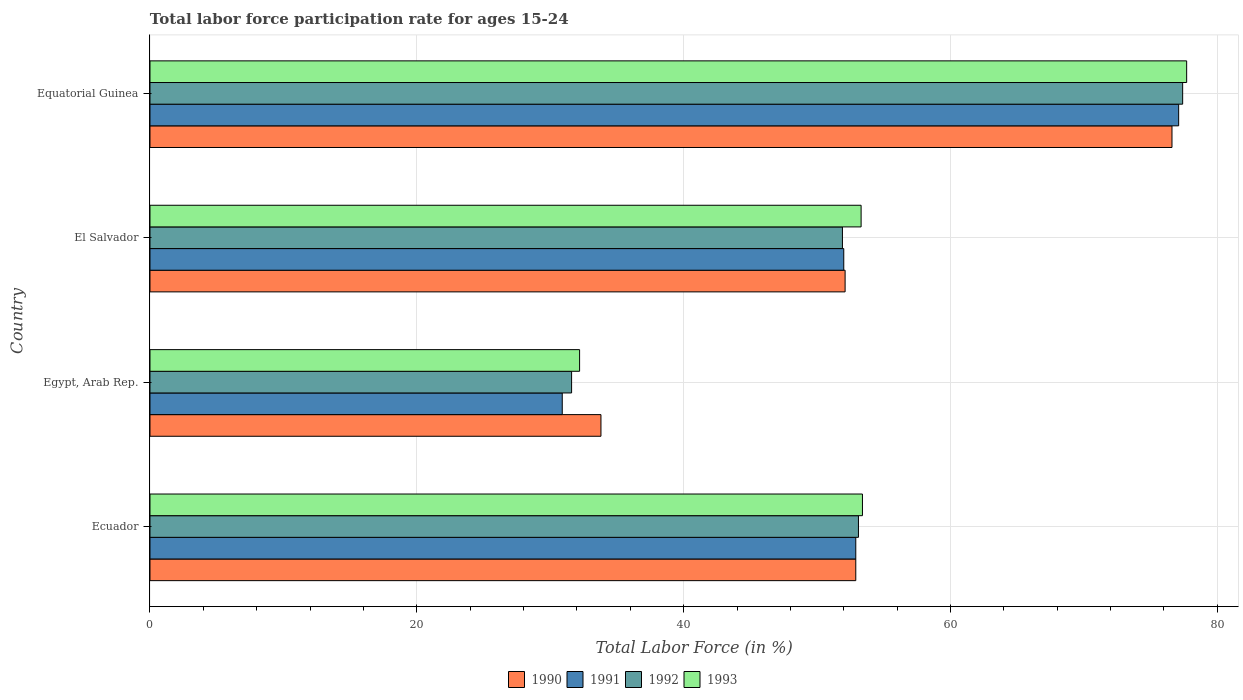How many different coloured bars are there?
Your answer should be very brief. 4. How many groups of bars are there?
Offer a terse response. 4. How many bars are there on the 4th tick from the bottom?
Ensure brevity in your answer.  4. What is the label of the 4th group of bars from the top?
Ensure brevity in your answer.  Ecuador. What is the labor force participation rate in 1991 in Egypt, Arab Rep.?
Provide a short and direct response. 30.9. Across all countries, what is the maximum labor force participation rate in 1990?
Make the answer very short. 76.6. Across all countries, what is the minimum labor force participation rate in 1991?
Your response must be concise. 30.9. In which country was the labor force participation rate in 1992 maximum?
Your response must be concise. Equatorial Guinea. In which country was the labor force participation rate in 1992 minimum?
Offer a terse response. Egypt, Arab Rep. What is the total labor force participation rate in 1990 in the graph?
Keep it short and to the point. 215.4. What is the difference between the labor force participation rate in 1993 in Egypt, Arab Rep. and that in El Salvador?
Your response must be concise. -21.1. What is the difference between the labor force participation rate in 1990 in Ecuador and the labor force participation rate in 1992 in Equatorial Guinea?
Your answer should be very brief. -24.5. What is the average labor force participation rate in 1991 per country?
Your answer should be very brief. 53.22. What is the difference between the labor force participation rate in 1992 and labor force participation rate in 1991 in El Salvador?
Offer a very short reply. -0.1. What is the ratio of the labor force participation rate in 1990 in Egypt, Arab Rep. to that in El Salvador?
Keep it short and to the point. 0.65. What is the difference between the highest and the second highest labor force participation rate in 1993?
Give a very brief answer. 24.3. What is the difference between the highest and the lowest labor force participation rate in 1993?
Keep it short and to the point. 45.5. In how many countries, is the labor force participation rate in 1991 greater than the average labor force participation rate in 1991 taken over all countries?
Make the answer very short. 1. What does the 4th bar from the top in Ecuador represents?
Make the answer very short. 1990. What does the 1st bar from the bottom in Ecuador represents?
Make the answer very short. 1990. How many bars are there?
Your answer should be compact. 16. How many countries are there in the graph?
Keep it short and to the point. 4. What is the difference between two consecutive major ticks on the X-axis?
Your response must be concise. 20. Are the values on the major ticks of X-axis written in scientific E-notation?
Provide a succinct answer. No. Does the graph contain grids?
Your response must be concise. Yes. Where does the legend appear in the graph?
Offer a very short reply. Bottom center. What is the title of the graph?
Ensure brevity in your answer.  Total labor force participation rate for ages 15-24. Does "1983" appear as one of the legend labels in the graph?
Give a very brief answer. No. What is the Total Labor Force (in %) of 1990 in Ecuador?
Provide a succinct answer. 52.9. What is the Total Labor Force (in %) in 1991 in Ecuador?
Give a very brief answer. 52.9. What is the Total Labor Force (in %) in 1992 in Ecuador?
Ensure brevity in your answer.  53.1. What is the Total Labor Force (in %) in 1993 in Ecuador?
Give a very brief answer. 53.4. What is the Total Labor Force (in %) of 1990 in Egypt, Arab Rep.?
Provide a short and direct response. 33.8. What is the Total Labor Force (in %) of 1991 in Egypt, Arab Rep.?
Provide a short and direct response. 30.9. What is the Total Labor Force (in %) in 1992 in Egypt, Arab Rep.?
Your response must be concise. 31.6. What is the Total Labor Force (in %) of 1993 in Egypt, Arab Rep.?
Provide a succinct answer. 32.2. What is the Total Labor Force (in %) of 1990 in El Salvador?
Your answer should be compact. 52.1. What is the Total Labor Force (in %) of 1991 in El Salvador?
Keep it short and to the point. 52. What is the Total Labor Force (in %) of 1992 in El Salvador?
Your answer should be compact. 51.9. What is the Total Labor Force (in %) in 1993 in El Salvador?
Provide a succinct answer. 53.3. What is the Total Labor Force (in %) in 1990 in Equatorial Guinea?
Provide a succinct answer. 76.6. What is the Total Labor Force (in %) of 1991 in Equatorial Guinea?
Your response must be concise. 77.1. What is the Total Labor Force (in %) in 1992 in Equatorial Guinea?
Make the answer very short. 77.4. What is the Total Labor Force (in %) of 1993 in Equatorial Guinea?
Make the answer very short. 77.7. Across all countries, what is the maximum Total Labor Force (in %) of 1990?
Offer a terse response. 76.6. Across all countries, what is the maximum Total Labor Force (in %) in 1991?
Your answer should be compact. 77.1. Across all countries, what is the maximum Total Labor Force (in %) of 1992?
Your answer should be compact. 77.4. Across all countries, what is the maximum Total Labor Force (in %) of 1993?
Offer a very short reply. 77.7. Across all countries, what is the minimum Total Labor Force (in %) in 1990?
Offer a terse response. 33.8. Across all countries, what is the minimum Total Labor Force (in %) of 1991?
Keep it short and to the point. 30.9. Across all countries, what is the minimum Total Labor Force (in %) of 1992?
Offer a very short reply. 31.6. Across all countries, what is the minimum Total Labor Force (in %) of 1993?
Offer a terse response. 32.2. What is the total Total Labor Force (in %) in 1990 in the graph?
Make the answer very short. 215.4. What is the total Total Labor Force (in %) of 1991 in the graph?
Make the answer very short. 212.9. What is the total Total Labor Force (in %) in 1992 in the graph?
Make the answer very short. 214. What is the total Total Labor Force (in %) in 1993 in the graph?
Give a very brief answer. 216.6. What is the difference between the Total Labor Force (in %) in 1993 in Ecuador and that in Egypt, Arab Rep.?
Give a very brief answer. 21.2. What is the difference between the Total Labor Force (in %) of 1991 in Ecuador and that in El Salvador?
Provide a short and direct response. 0.9. What is the difference between the Total Labor Force (in %) of 1993 in Ecuador and that in El Salvador?
Keep it short and to the point. 0.1. What is the difference between the Total Labor Force (in %) of 1990 in Ecuador and that in Equatorial Guinea?
Offer a very short reply. -23.7. What is the difference between the Total Labor Force (in %) of 1991 in Ecuador and that in Equatorial Guinea?
Offer a very short reply. -24.2. What is the difference between the Total Labor Force (in %) of 1992 in Ecuador and that in Equatorial Guinea?
Offer a terse response. -24.3. What is the difference between the Total Labor Force (in %) of 1993 in Ecuador and that in Equatorial Guinea?
Ensure brevity in your answer.  -24.3. What is the difference between the Total Labor Force (in %) of 1990 in Egypt, Arab Rep. and that in El Salvador?
Provide a short and direct response. -18.3. What is the difference between the Total Labor Force (in %) of 1991 in Egypt, Arab Rep. and that in El Salvador?
Make the answer very short. -21.1. What is the difference between the Total Labor Force (in %) of 1992 in Egypt, Arab Rep. and that in El Salvador?
Your answer should be compact. -20.3. What is the difference between the Total Labor Force (in %) in 1993 in Egypt, Arab Rep. and that in El Salvador?
Provide a short and direct response. -21.1. What is the difference between the Total Labor Force (in %) of 1990 in Egypt, Arab Rep. and that in Equatorial Guinea?
Provide a short and direct response. -42.8. What is the difference between the Total Labor Force (in %) in 1991 in Egypt, Arab Rep. and that in Equatorial Guinea?
Provide a succinct answer. -46.2. What is the difference between the Total Labor Force (in %) in 1992 in Egypt, Arab Rep. and that in Equatorial Guinea?
Provide a succinct answer. -45.8. What is the difference between the Total Labor Force (in %) in 1993 in Egypt, Arab Rep. and that in Equatorial Guinea?
Offer a very short reply. -45.5. What is the difference between the Total Labor Force (in %) of 1990 in El Salvador and that in Equatorial Guinea?
Ensure brevity in your answer.  -24.5. What is the difference between the Total Labor Force (in %) in 1991 in El Salvador and that in Equatorial Guinea?
Offer a very short reply. -25.1. What is the difference between the Total Labor Force (in %) of 1992 in El Salvador and that in Equatorial Guinea?
Offer a very short reply. -25.5. What is the difference between the Total Labor Force (in %) of 1993 in El Salvador and that in Equatorial Guinea?
Offer a very short reply. -24.4. What is the difference between the Total Labor Force (in %) in 1990 in Ecuador and the Total Labor Force (in %) in 1992 in Egypt, Arab Rep.?
Your answer should be compact. 21.3. What is the difference between the Total Labor Force (in %) of 1990 in Ecuador and the Total Labor Force (in %) of 1993 in Egypt, Arab Rep.?
Ensure brevity in your answer.  20.7. What is the difference between the Total Labor Force (in %) of 1991 in Ecuador and the Total Labor Force (in %) of 1992 in Egypt, Arab Rep.?
Your response must be concise. 21.3. What is the difference between the Total Labor Force (in %) of 1991 in Ecuador and the Total Labor Force (in %) of 1993 in Egypt, Arab Rep.?
Your answer should be very brief. 20.7. What is the difference between the Total Labor Force (in %) in 1992 in Ecuador and the Total Labor Force (in %) in 1993 in Egypt, Arab Rep.?
Provide a short and direct response. 20.9. What is the difference between the Total Labor Force (in %) of 1990 in Ecuador and the Total Labor Force (in %) of 1992 in El Salvador?
Offer a terse response. 1. What is the difference between the Total Labor Force (in %) in 1990 in Ecuador and the Total Labor Force (in %) in 1993 in El Salvador?
Offer a very short reply. -0.4. What is the difference between the Total Labor Force (in %) of 1991 in Ecuador and the Total Labor Force (in %) of 1993 in El Salvador?
Offer a terse response. -0.4. What is the difference between the Total Labor Force (in %) in 1992 in Ecuador and the Total Labor Force (in %) in 1993 in El Salvador?
Keep it short and to the point. -0.2. What is the difference between the Total Labor Force (in %) of 1990 in Ecuador and the Total Labor Force (in %) of 1991 in Equatorial Guinea?
Give a very brief answer. -24.2. What is the difference between the Total Labor Force (in %) in 1990 in Ecuador and the Total Labor Force (in %) in 1992 in Equatorial Guinea?
Provide a succinct answer. -24.5. What is the difference between the Total Labor Force (in %) in 1990 in Ecuador and the Total Labor Force (in %) in 1993 in Equatorial Guinea?
Your response must be concise. -24.8. What is the difference between the Total Labor Force (in %) in 1991 in Ecuador and the Total Labor Force (in %) in 1992 in Equatorial Guinea?
Provide a succinct answer. -24.5. What is the difference between the Total Labor Force (in %) of 1991 in Ecuador and the Total Labor Force (in %) of 1993 in Equatorial Guinea?
Provide a short and direct response. -24.8. What is the difference between the Total Labor Force (in %) in 1992 in Ecuador and the Total Labor Force (in %) in 1993 in Equatorial Guinea?
Make the answer very short. -24.6. What is the difference between the Total Labor Force (in %) in 1990 in Egypt, Arab Rep. and the Total Labor Force (in %) in 1991 in El Salvador?
Offer a terse response. -18.2. What is the difference between the Total Labor Force (in %) in 1990 in Egypt, Arab Rep. and the Total Labor Force (in %) in 1992 in El Salvador?
Keep it short and to the point. -18.1. What is the difference between the Total Labor Force (in %) in 1990 in Egypt, Arab Rep. and the Total Labor Force (in %) in 1993 in El Salvador?
Provide a short and direct response. -19.5. What is the difference between the Total Labor Force (in %) of 1991 in Egypt, Arab Rep. and the Total Labor Force (in %) of 1993 in El Salvador?
Your answer should be compact. -22.4. What is the difference between the Total Labor Force (in %) in 1992 in Egypt, Arab Rep. and the Total Labor Force (in %) in 1993 in El Salvador?
Provide a succinct answer. -21.7. What is the difference between the Total Labor Force (in %) in 1990 in Egypt, Arab Rep. and the Total Labor Force (in %) in 1991 in Equatorial Guinea?
Offer a terse response. -43.3. What is the difference between the Total Labor Force (in %) in 1990 in Egypt, Arab Rep. and the Total Labor Force (in %) in 1992 in Equatorial Guinea?
Your answer should be very brief. -43.6. What is the difference between the Total Labor Force (in %) in 1990 in Egypt, Arab Rep. and the Total Labor Force (in %) in 1993 in Equatorial Guinea?
Provide a short and direct response. -43.9. What is the difference between the Total Labor Force (in %) of 1991 in Egypt, Arab Rep. and the Total Labor Force (in %) of 1992 in Equatorial Guinea?
Make the answer very short. -46.5. What is the difference between the Total Labor Force (in %) in 1991 in Egypt, Arab Rep. and the Total Labor Force (in %) in 1993 in Equatorial Guinea?
Give a very brief answer. -46.8. What is the difference between the Total Labor Force (in %) of 1992 in Egypt, Arab Rep. and the Total Labor Force (in %) of 1993 in Equatorial Guinea?
Your response must be concise. -46.1. What is the difference between the Total Labor Force (in %) of 1990 in El Salvador and the Total Labor Force (in %) of 1991 in Equatorial Guinea?
Make the answer very short. -25. What is the difference between the Total Labor Force (in %) of 1990 in El Salvador and the Total Labor Force (in %) of 1992 in Equatorial Guinea?
Provide a succinct answer. -25.3. What is the difference between the Total Labor Force (in %) of 1990 in El Salvador and the Total Labor Force (in %) of 1993 in Equatorial Guinea?
Make the answer very short. -25.6. What is the difference between the Total Labor Force (in %) in 1991 in El Salvador and the Total Labor Force (in %) in 1992 in Equatorial Guinea?
Your response must be concise. -25.4. What is the difference between the Total Labor Force (in %) of 1991 in El Salvador and the Total Labor Force (in %) of 1993 in Equatorial Guinea?
Offer a very short reply. -25.7. What is the difference between the Total Labor Force (in %) of 1992 in El Salvador and the Total Labor Force (in %) of 1993 in Equatorial Guinea?
Your answer should be compact. -25.8. What is the average Total Labor Force (in %) of 1990 per country?
Provide a short and direct response. 53.85. What is the average Total Labor Force (in %) of 1991 per country?
Give a very brief answer. 53.23. What is the average Total Labor Force (in %) of 1992 per country?
Ensure brevity in your answer.  53.5. What is the average Total Labor Force (in %) of 1993 per country?
Provide a short and direct response. 54.15. What is the difference between the Total Labor Force (in %) of 1990 and Total Labor Force (in %) of 1991 in Ecuador?
Ensure brevity in your answer.  0. What is the difference between the Total Labor Force (in %) of 1991 and Total Labor Force (in %) of 1992 in Ecuador?
Ensure brevity in your answer.  -0.2. What is the difference between the Total Labor Force (in %) of 1990 and Total Labor Force (in %) of 1993 in Egypt, Arab Rep.?
Keep it short and to the point. 1.6. What is the difference between the Total Labor Force (in %) of 1991 and Total Labor Force (in %) of 1992 in Egypt, Arab Rep.?
Your response must be concise. -0.7. What is the difference between the Total Labor Force (in %) of 1991 and Total Labor Force (in %) of 1993 in Egypt, Arab Rep.?
Give a very brief answer. -1.3. What is the difference between the Total Labor Force (in %) of 1990 and Total Labor Force (in %) of 1992 in El Salvador?
Offer a very short reply. 0.2. What is the difference between the Total Labor Force (in %) in 1991 and Total Labor Force (in %) in 1993 in El Salvador?
Keep it short and to the point. -1.3. What is the difference between the Total Labor Force (in %) in 1990 and Total Labor Force (in %) in 1991 in Equatorial Guinea?
Keep it short and to the point. -0.5. What is the difference between the Total Labor Force (in %) in 1991 and Total Labor Force (in %) in 1993 in Equatorial Guinea?
Ensure brevity in your answer.  -0.6. What is the difference between the Total Labor Force (in %) in 1992 and Total Labor Force (in %) in 1993 in Equatorial Guinea?
Provide a short and direct response. -0.3. What is the ratio of the Total Labor Force (in %) of 1990 in Ecuador to that in Egypt, Arab Rep.?
Offer a very short reply. 1.57. What is the ratio of the Total Labor Force (in %) of 1991 in Ecuador to that in Egypt, Arab Rep.?
Your answer should be compact. 1.71. What is the ratio of the Total Labor Force (in %) of 1992 in Ecuador to that in Egypt, Arab Rep.?
Offer a very short reply. 1.68. What is the ratio of the Total Labor Force (in %) in 1993 in Ecuador to that in Egypt, Arab Rep.?
Your answer should be compact. 1.66. What is the ratio of the Total Labor Force (in %) of 1990 in Ecuador to that in El Salvador?
Your response must be concise. 1.02. What is the ratio of the Total Labor Force (in %) of 1991 in Ecuador to that in El Salvador?
Offer a terse response. 1.02. What is the ratio of the Total Labor Force (in %) in 1992 in Ecuador to that in El Salvador?
Offer a very short reply. 1.02. What is the ratio of the Total Labor Force (in %) of 1990 in Ecuador to that in Equatorial Guinea?
Keep it short and to the point. 0.69. What is the ratio of the Total Labor Force (in %) in 1991 in Ecuador to that in Equatorial Guinea?
Ensure brevity in your answer.  0.69. What is the ratio of the Total Labor Force (in %) of 1992 in Ecuador to that in Equatorial Guinea?
Give a very brief answer. 0.69. What is the ratio of the Total Labor Force (in %) in 1993 in Ecuador to that in Equatorial Guinea?
Ensure brevity in your answer.  0.69. What is the ratio of the Total Labor Force (in %) in 1990 in Egypt, Arab Rep. to that in El Salvador?
Ensure brevity in your answer.  0.65. What is the ratio of the Total Labor Force (in %) of 1991 in Egypt, Arab Rep. to that in El Salvador?
Ensure brevity in your answer.  0.59. What is the ratio of the Total Labor Force (in %) of 1992 in Egypt, Arab Rep. to that in El Salvador?
Keep it short and to the point. 0.61. What is the ratio of the Total Labor Force (in %) in 1993 in Egypt, Arab Rep. to that in El Salvador?
Ensure brevity in your answer.  0.6. What is the ratio of the Total Labor Force (in %) of 1990 in Egypt, Arab Rep. to that in Equatorial Guinea?
Ensure brevity in your answer.  0.44. What is the ratio of the Total Labor Force (in %) in 1991 in Egypt, Arab Rep. to that in Equatorial Guinea?
Your answer should be very brief. 0.4. What is the ratio of the Total Labor Force (in %) in 1992 in Egypt, Arab Rep. to that in Equatorial Guinea?
Provide a succinct answer. 0.41. What is the ratio of the Total Labor Force (in %) of 1993 in Egypt, Arab Rep. to that in Equatorial Guinea?
Ensure brevity in your answer.  0.41. What is the ratio of the Total Labor Force (in %) of 1990 in El Salvador to that in Equatorial Guinea?
Ensure brevity in your answer.  0.68. What is the ratio of the Total Labor Force (in %) of 1991 in El Salvador to that in Equatorial Guinea?
Your answer should be very brief. 0.67. What is the ratio of the Total Labor Force (in %) of 1992 in El Salvador to that in Equatorial Guinea?
Provide a short and direct response. 0.67. What is the ratio of the Total Labor Force (in %) of 1993 in El Salvador to that in Equatorial Guinea?
Provide a short and direct response. 0.69. What is the difference between the highest and the second highest Total Labor Force (in %) in 1990?
Offer a terse response. 23.7. What is the difference between the highest and the second highest Total Labor Force (in %) in 1991?
Your answer should be very brief. 24.2. What is the difference between the highest and the second highest Total Labor Force (in %) of 1992?
Give a very brief answer. 24.3. What is the difference between the highest and the second highest Total Labor Force (in %) of 1993?
Ensure brevity in your answer.  24.3. What is the difference between the highest and the lowest Total Labor Force (in %) in 1990?
Offer a terse response. 42.8. What is the difference between the highest and the lowest Total Labor Force (in %) in 1991?
Your answer should be compact. 46.2. What is the difference between the highest and the lowest Total Labor Force (in %) in 1992?
Offer a very short reply. 45.8. What is the difference between the highest and the lowest Total Labor Force (in %) of 1993?
Offer a very short reply. 45.5. 